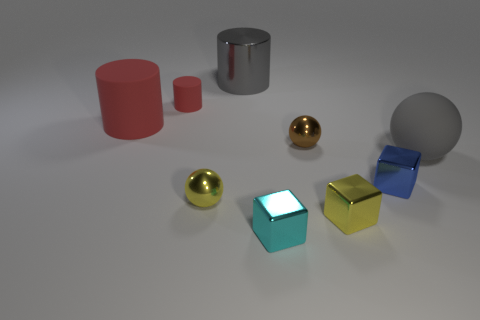If you were to categorize these objects, how would you group them? One could categorize these objects based on shape, color, size, or texture. For instance, there are two categories of shapes: cylindrical and spherical. In terms of texture, objects are either reflective or matte. If we go by color, each object is distinct except for the two golden spheres, which share a hue. Size-wise, they can be grouped into smaller and larger objects. 